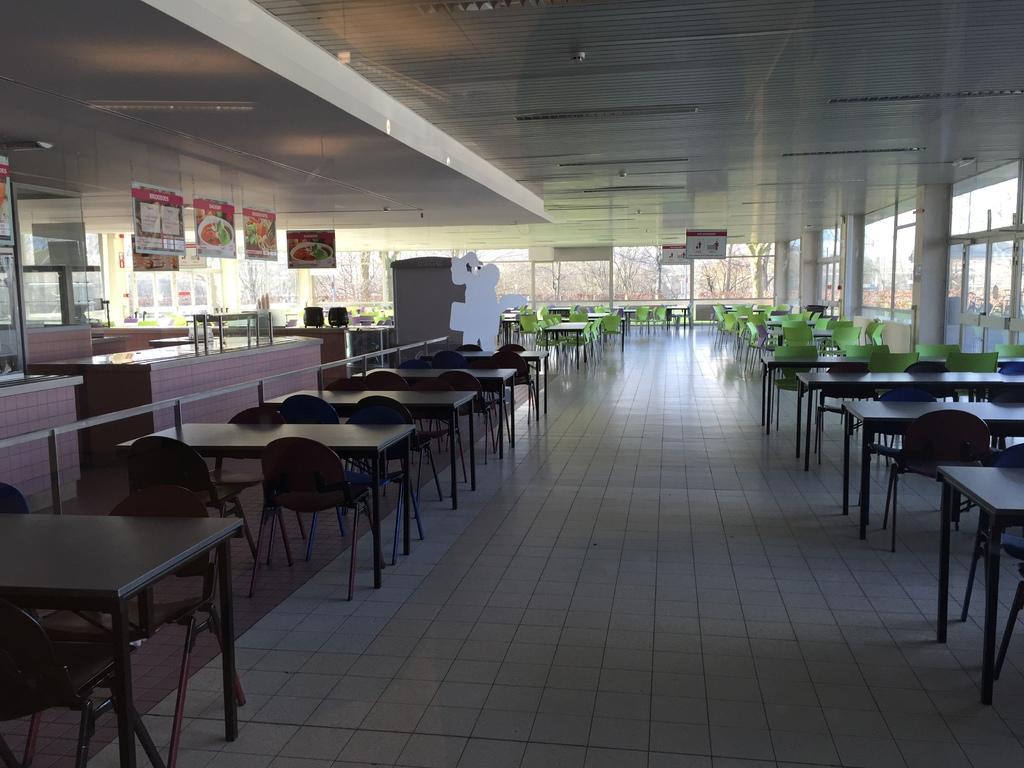In one or two sentences, can you explain what this image depicts? This picture is clicked inside the hall. In the center we can see the tables, chairs, counters and the many other objects. At the top there is a roof and the ceiling lights. In the background we can see the banners on which we can see the pictures of food items and we can see the windows and through the windows we can see the outside view. 